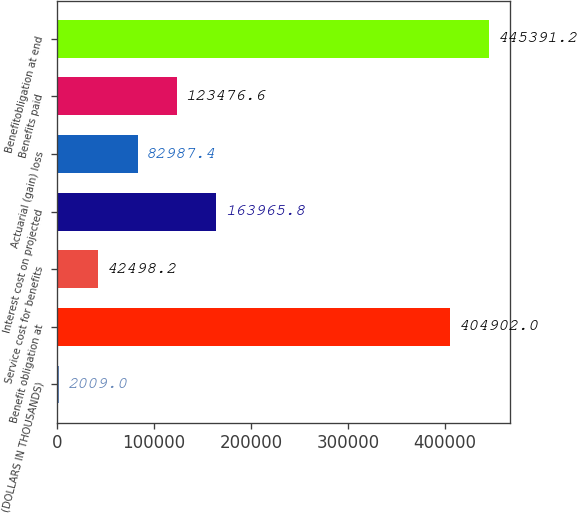Convert chart. <chart><loc_0><loc_0><loc_500><loc_500><bar_chart><fcel>(DOLLARS IN THOUSANDS)<fcel>Benefit obligation at<fcel>Service cost for benefits<fcel>Interest cost on projected<fcel>Actuarial (gain) loss<fcel>Benefits paid<fcel>Benefitobligation at end<nl><fcel>2009<fcel>404902<fcel>42498.2<fcel>163966<fcel>82987.4<fcel>123477<fcel>445391<nl></chart> 